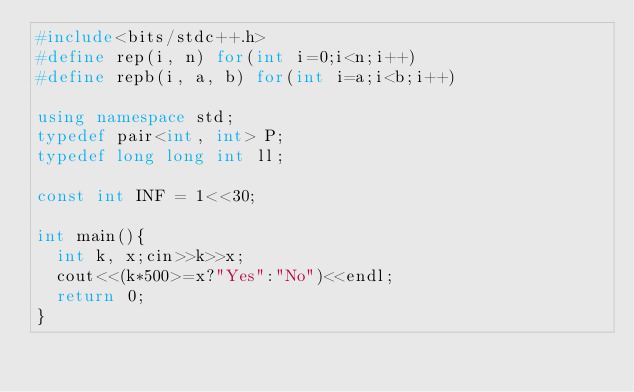<code> <loc_0><loc_0><loc_500><loc_500><_C++_>#include<bits/stdc++.h>
#define rep(i, n) for(int i=0;i<n;i++)
#define repb(i, a, b) for(int i=a;i<b;i++)

using namespace std;
typedef pair<int, int> P;
typedef long long int ll;

const int INF = 1<<30;

int main(){
  int k, x;cin>>k>>x;
  cout<<(k*500>=x?"Yes":"No")<<endl;
  return 0;
}
</code> 